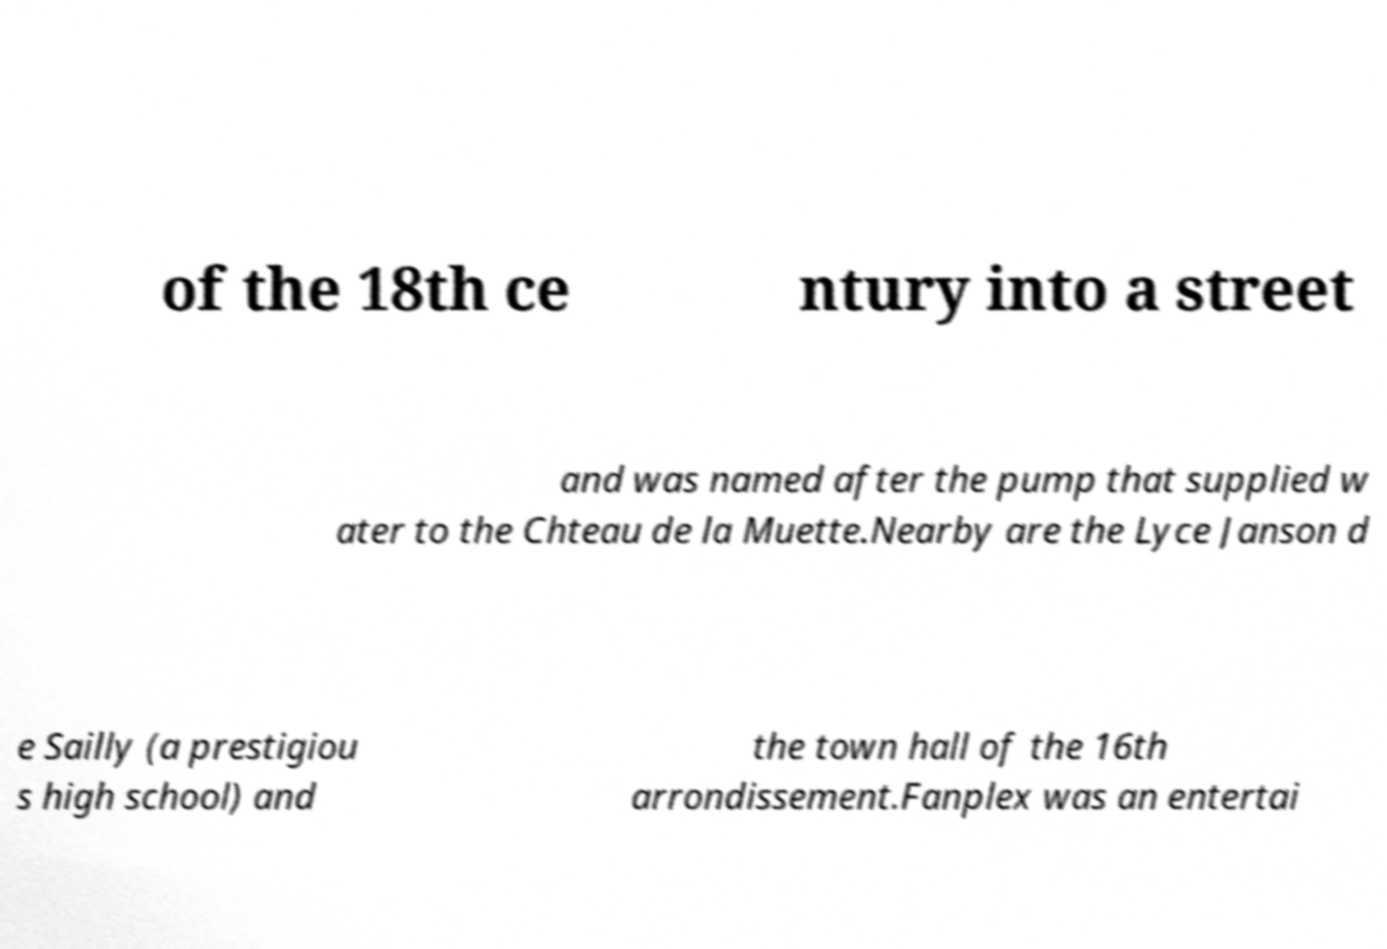Can you read and provide the text displayed in the image?This photo seems to have some interesting text. Can you extract and type it out for me? of the 18th ce ntury into a street and was named after the pump that supplied w ater to the Chteau de la Muette.Nearby are the Lyce Janson d e Sailly (a prestigiou s high school) and the town hall of the 16th arrondissement.Fanplex was an entertai 